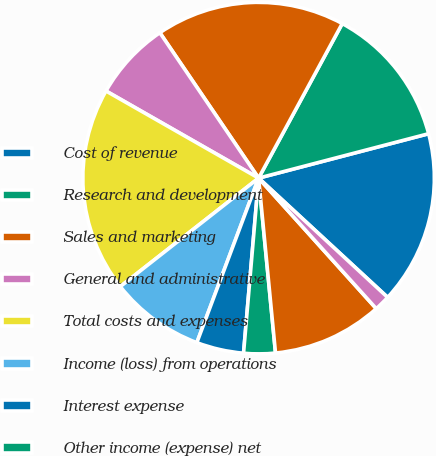Convert chart to OTSL. <chart><loc_0><loc_0><loc_500><loc_500><pie_chart><fcel>Cost of revenue<fcel>Research and development<fcel>Sales and marketing<fcel>General and administrative<fcel>Total costs and expenses<fcel>Income (loss) from operations<fcel>Interest expense<fcel>Other income (expense) net<fcel>Loss before income taxes<fcel>Provision (benefit) for income<nl><fcel>15.94%<fcel>13.04%<fcel>17.39%<fcel>7.25%<fcel>18.84%<fcel>8.7%<fcel>4.35%<fcel>2.9%<fcel>10.14%<fcel>1.45%<nl></chart> 